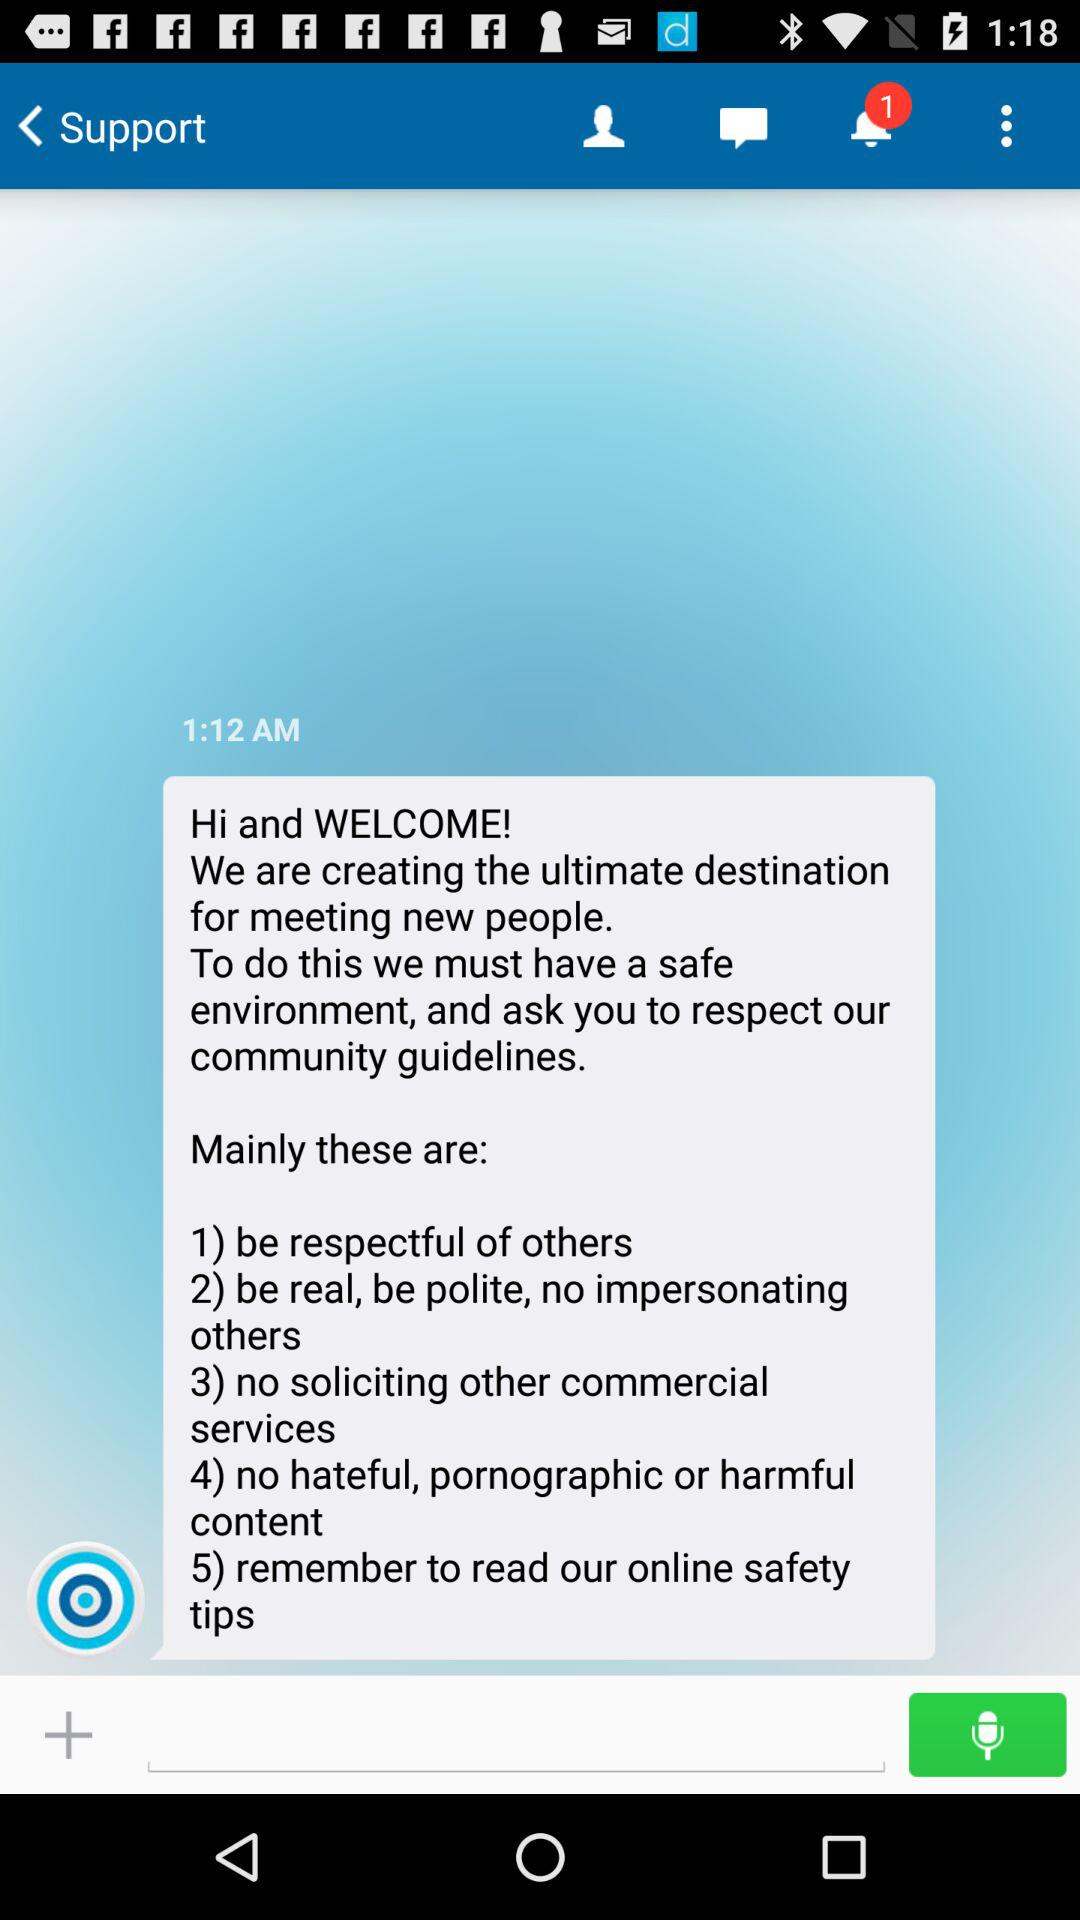How many guidelines are about respecting others?
Answer the question using a single word or phrase. 1 